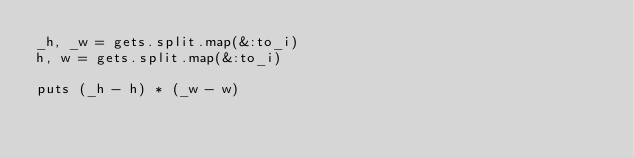Convert code to text. <code><loc_0><loc_0><loc_500><loc_500><_Ruby_>_h, _w = gets.split.map(&:to_i)
h, w = gets.split.map(&:to_i)

puts (_h - h) * (_w - w)</code> 